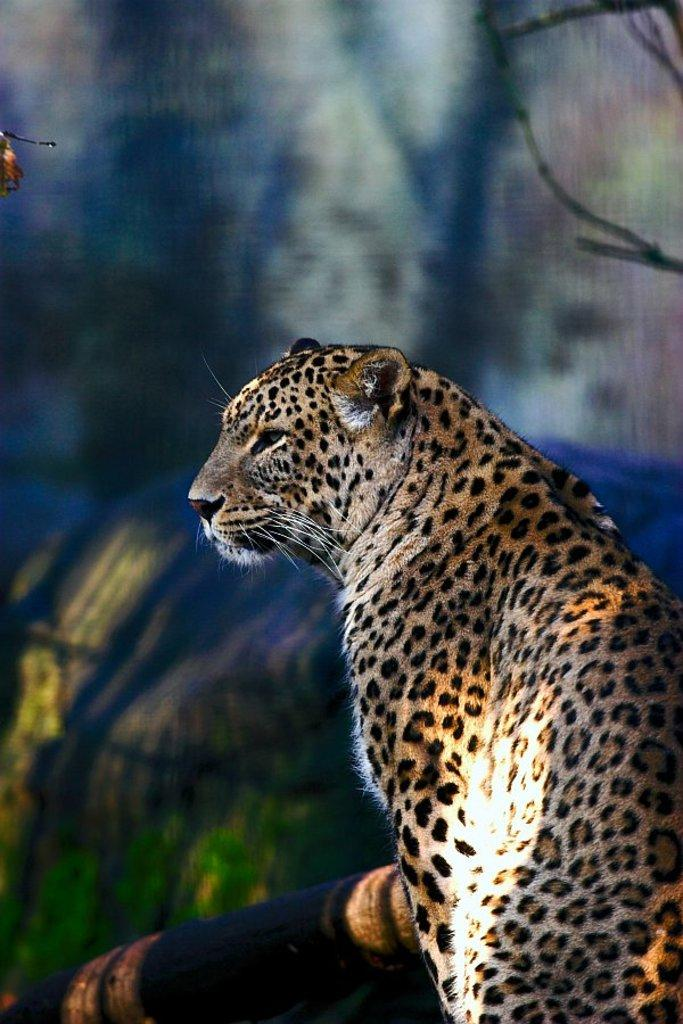What animal is the main subject of the image? There is a cheetah in the image. What is the cheetah doing in the image? The cheetah is sitting in the image. Which direction is the cheetah looking? The cheetah is looking at the left side in the image. What object can be seen in the image besides the cheetah? There is a trunk visible in the image. How would you describe the background of the image? The background of the image is blurred. What type of key is the cheetah holding in its paw in the image? There is no key present in the image; the cheetah is not holding anything. 